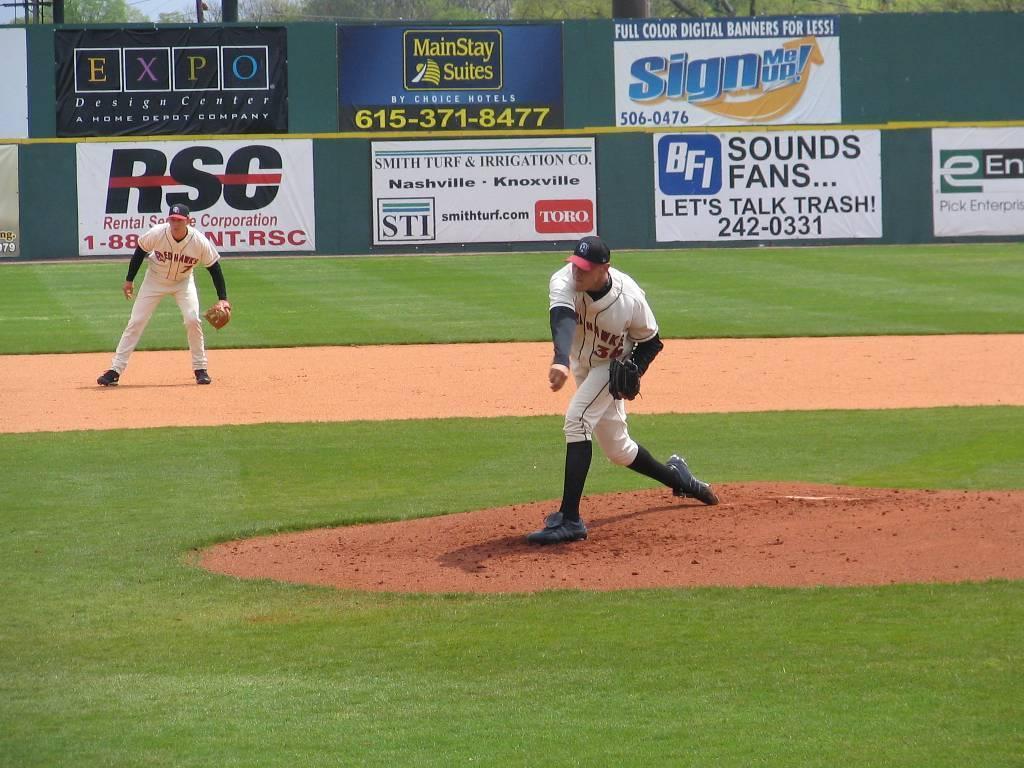What's the number to talk trash?
Keep it short and to the point. 242-0331. If we want to talk trash what phone number do we call?
Offer a very short reply. 242-0331. 